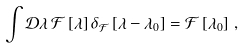<formula> <loc_0><loc_0><loc_500><loc_500>\int \mathcal { D } \lambda \, \mathcal { F } \left [ \lambda \right ] \delta _ { \mathcal { F } } \left [ \lambda - \lambda _ { 0 } \right ] = \mathcal { F } \left [ \lambda _ { 0 } \right ] \, ,</formula> 